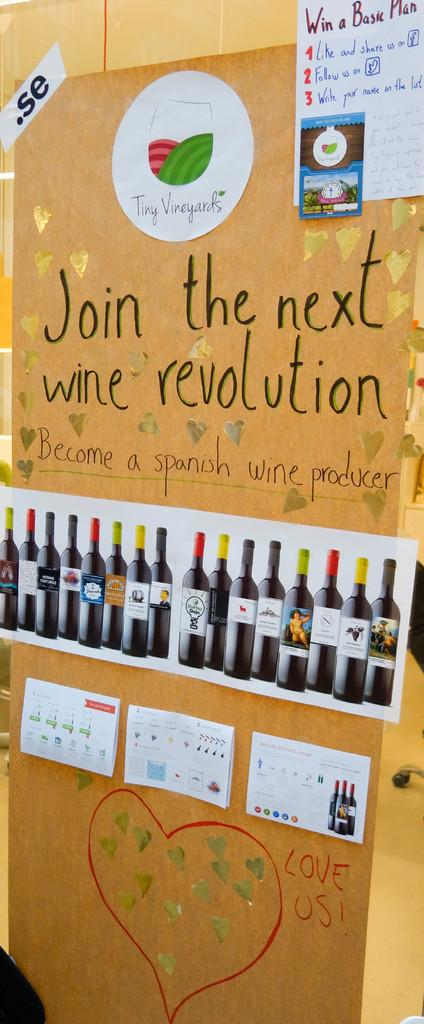<image>
Give a short and clear explanation of the subsequent image. A large yellow sheet of paper with pictures of wine bottles that says Join the next wine revolution 